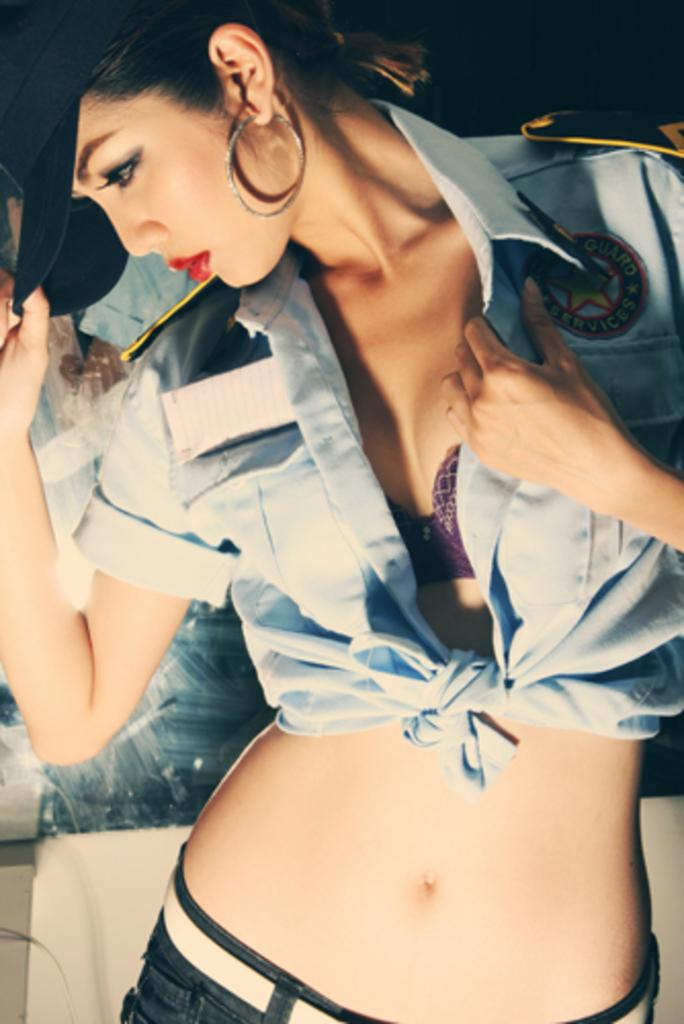What is the main subject of the image? There is a person standing in the image. What is the person holding in the image? The person is holding a cap. What can be seen in the background of the image? There is a poster attached to the wall in the background of the image. What type of cheese is being advertised on the poster in the image? There is no cheese or advertisement present on the poster in the image; it is simply a poster attached to the wall. 